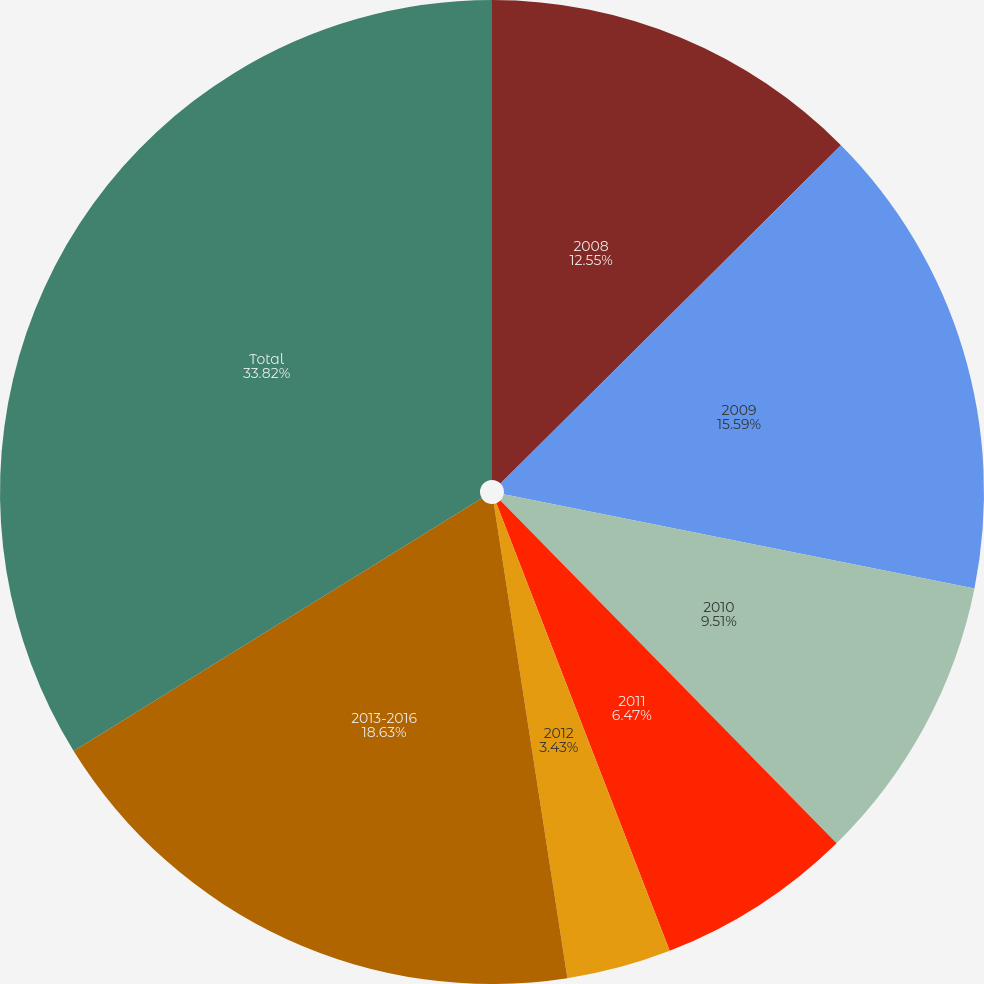Convert chart to OTSL. <chart><loc_0><loc_0><loc_500><loc_500><pie_chart><fcel>2008<fcel>2009<fcel>2010<fcel>2011<fcel>2012<fcel>2013-2016<fcel>Total<nl><fcel>12.55%<fcel>15.59%<fcel>9.51%<fcel>6.47%<fcel>3.43%<fcel>18.63%<fcel>33.82%<nl></chart> 